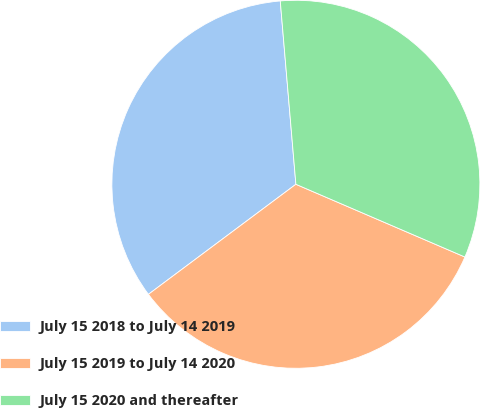Convert chart to OTSL. <chart><loc_0><loc_0><loc_500><loc_500><pie_chart><fcel>July 15 2018 to July 14 2019<fcel>July 15 2019 to July 14 2020<fcel>July 15 2020 and thereafter<nl><fcel>33.85%<fcel>33.33%<fcel>32.82%<nl></chart> 